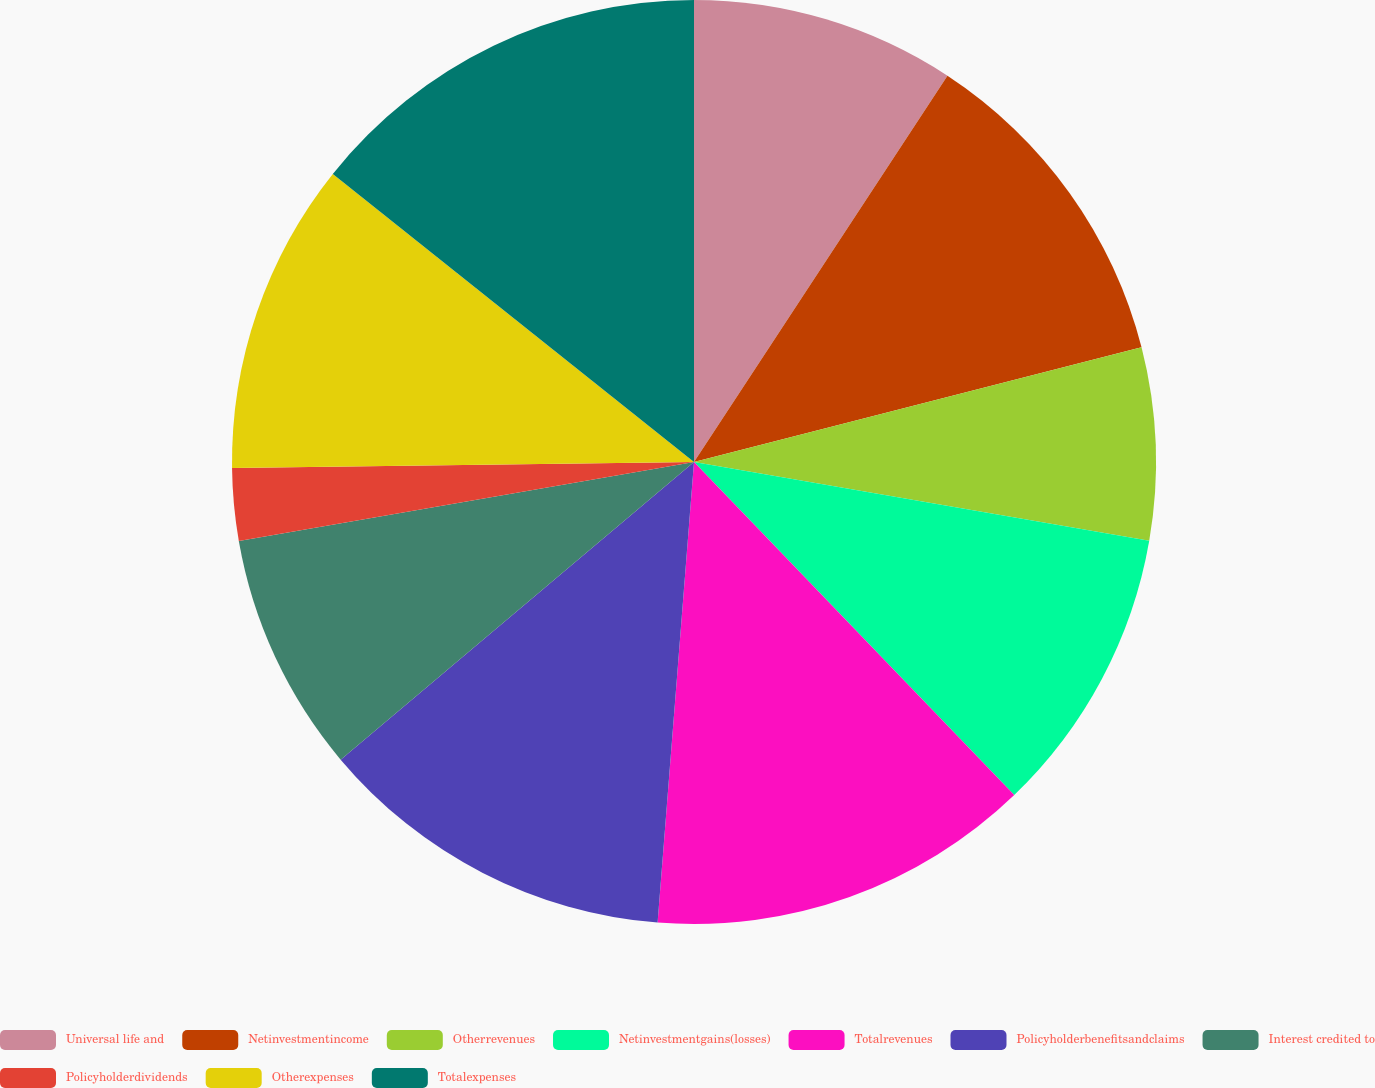Convert chart to OTSL. <chart><loc_0><loc_0><loc_500><loc_500><pie_chart><fcel>Universal life and<fcel>Netinvestmentincome<fcel>Otherrevenues<fcel>Netinvestmentgains(losses)<fcel>Totalrevenues<fcel>Policyholderbenefitsandclaims<fcel>Interest credited to<fcel>Policyholderdividends<fcel>Otherexpenses<fcel>Totalexpenses<nl><fcel>9.24%<fcel>11.76%<fcel>6.72%<fcel>10.08%<fcel>13.44%<fcel>12.6%<fcel>8.4%<fcel>2.53%<fcel>10.92%<fcel>14.28%<nl></chart> 